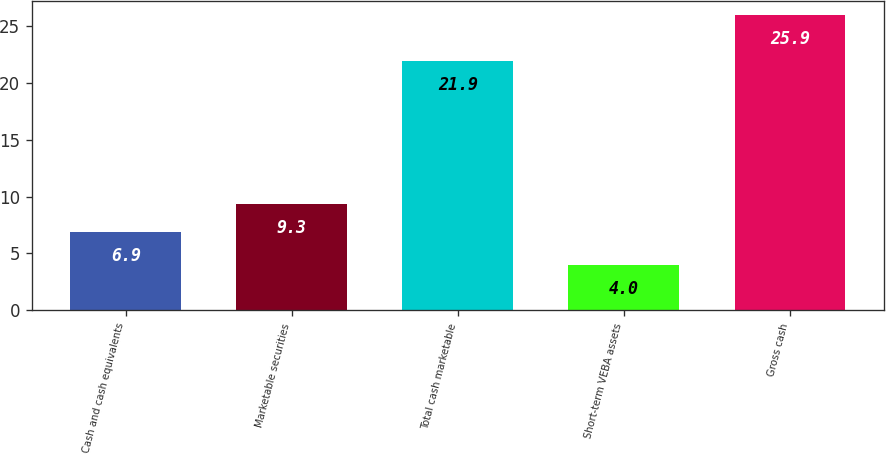<chart> <loc_0><loc_0><loc_500><loc_500><bar_chart><fcel>Cash and cash equivalents<fcel>Marketable securities<fcel>Total cash marketable<fcel>Short-term VEBA assets<fcel>Gross cash<nl><fcel>6.9<fcel>9.3<fcel>21.9<fcel>4<fcel>25.9<nl></chart> 